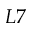Convert formula to latex. <formula><loc_0><loc_0><loc_500><loc_500>L 7</formula> 